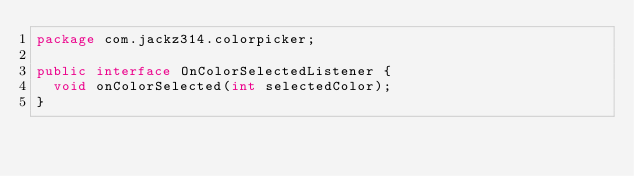Convert code to text. <code><loc_0><loc_0><loc_500><loc_500><_Java_>package com.jackz314.colorpicker;

public interface OnColorSelectedListener {
	void onColorSelected(int selectedColor);
}
</code> 